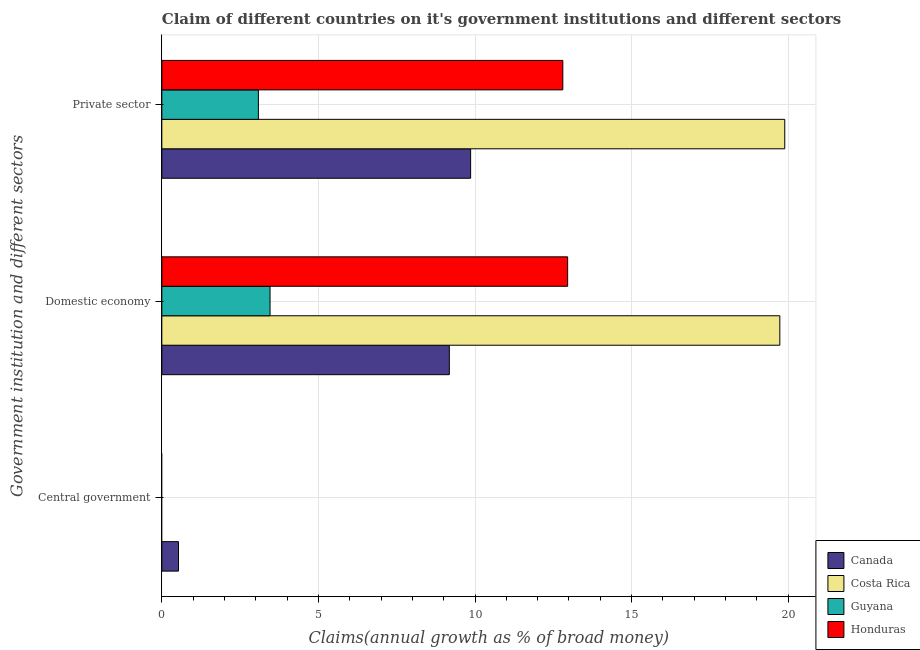Are the number of bars per tick equal to the number of legend labels?
Offer a very short reply. No. Are the number of bars on each tick of the Y-axis equal?
Give a very brief answer. No. How many bars are there on the 2nd tick from the top?
Offer a terse response. 4. How many bars are there on the 2nd tick from the bottom?
Provide a succinct answer. 4. What is the label of the 2nd group of bars from the top?
Keep it short and to the point. Domestic economy. What is the percentage of claim on the private sector in Canada?
Provide a succinct answer. 9.86. Across all countries, what is the maximum percentage of claim on the domestic economy?
Offer a terse response. 19.73. Across all countries, what is the minimum percentage of claim on the private sector?
Offer a very short reply. 3.08. In which country was the percentage of claim on the private sector maximum?
Provide a short and direct response. Costa Rica. What is the total percentage of claim on the domestic economy in the graph?
Make the answer very short. 45.33. What is the difference between the percentage of claim on the domestic economy in Guyana and that in Honduras?
Your answer should be compact. -9.5. What is the difference between the percentage of claim on the domestic economy in Costa Rica and the percentage of claim on the private sector in Canada?
Your response must be concise. 9.87. What is the average percentage of claim on the private sector per country?
Your answer should be compact. 11.41. What is the difference between the percentage of claim on the domestic economy and percentage of claim on the central government in Canada?
Provide a succinct answer. 8.65. What is the ratio of the percentage of claim on the domestic economy in Costa Rica to that in Honduras?
Provide a succinct answer. 1.52. Is the difference between the percentage of claim on the private sector in Guyana and Canada greater than the difference between the percentage of claim on the domestic economy in Guyana and Canada?
Ensure brevity in your answer.  No. What is the difference between the highest and the second highest percentage of claim on the private sector?
Make the answer very short. 7.09. What is the difference between the highest and the lowest percentage of claim on the private sector?
Provide a succinct answer. 16.81. How many bars are there?
Give a very brief answer. 9. Are all the bars in the graph horizontal?
Provide a succinct answer. Yes. How many countries are there in the graph?
Keep it short and to the point. 4. What is the difference between two consecutive major ticks on the X-axis?
Your response must be concise. 5. Does the graph contain any zero values?
Provide a succinct answer. Yes. Where does the legend appear in the graph?
Give a very brief answer. Bottom right. How many legend labels are there?
Your response must be concise. 4. What is the title of the graph?
Offer a terse response. Claim of different countries on it's government institutions and different sectors. Does "Sri Lanka" appear as one of the legend labels in the graph?
Offer a very short reply. No. What is the label or title of the X-axis?
Keep it short and to the point. Claims(annual growth as % of broad money). What is the label or title of the Y-axis?
Offer a very short reply. Government institution and different sectors. What is the Claims(annual growth as % of broad money) of Canada in Central government?
Provide a succinct answer. 0.53. What is the Claims(annual growth as % of broad money) in Costa Rica in Central government?
Give a very brief answer. 0. What is the Claims(annual growth as % of broad money) in Guyana in Central government?
Provide a succinct answer. 0. What is the Claims(annual growth as % of broad money) of Canada in Domestic economy?
Offer a very short reply. 9.18. What is the Claims(annual growth as % of broad money) in Costa Rica in Domestic economy?
Your answer should be very brief. 19.73. What is the Claims(annual growth as % of broad money) of Guyana in Domestic economy?
Keep it short and to the point. 3.46. What is the Claims(annual growth as % of broad money) of Honduras in Domestic economy?
Offer a very short reply. 12.96. What is the Claims(annual growth as % of broad money) of Canada in Private sector?
Your response must be concise. 9.86. What is the Claims(annual growth as % of broad money) in Costa Rica in Private sector?
Keep it short and to the point. 19.89. What is the Claims(annual growth as % of broad money) of Guyana in Private sector?
Provide a short and direct response. 3.08. What is the Claims(annual growth as % of broad money) in Honduras in Private sector?
Give a very brief answer. 12.8. Across all Government institution and different sectors, what is the maximum Claims(annual growth as % of broad money) of Canada?
Your answer should be very brief. 9.86. Across all Government institution and different sectors, what is the maximum Claims(annual growth as % of broad money) in Costa Rica?
Keep it short and to the point. 19.89. Across all Government institution and different sectors, what is the maximum Claims(annual growth as % of broad money) of Guyana?
Offer a very short reply. 3.46. Across all Government institution and different sectors, what is the maximum Claims(annual growth as % of broad money) of Honduras?
Your answer should be very brief. 12.96. Across all Government institution and different sectors, what is the minimum Claims(annual growth as % of broad money) in Canada?
Your answer should be compact. 0.53. Across all Government institution and different sectors, what is the minimum Claims(annual growth as % of broad money) of Costa Rica?
Provide a short and direct response. 0. What is the total Claims(annual growth as % of broad money) of Canada in the graph?
Give a very brief answer. 19.57. What is the total Claims(annual growth as % of broad money) of Costa Rica in the graph?
Offer a terse response. 39.62. What is the total Claims(annual growth as % of broad money) in Guyana in the graph?
Provide a succinct answer. 6.54. What is the total Claims(annual growth as % of broad money) of Honduras in the graph?
Give a very brief answer. 25.76. What is the difference between the Claims(annual growth as % of broad money) in Canada in Central government and that in Domestic economy?
Your answer should be compact. -8.65. What is the difference between the Claims(annual growth as % of broad money) of Canada in Central government and that in Private sector?
Your answer should be compact. -9.33. What is the difference between the Claims(annual growth as % of broad money) of Canada in Domestic economy and that in Private sector?
Give a very brief answer. -0.68. What is the difference between the Claims(annual growth as % of broad money) in Costa Rica in Domestic economy and that in Private sector?
Make the answer very short. -0.16. What is the difference between the Claims(annual growth as % of broad money) of Guyana in Domestic economy and that in Private sector?
Provide a succinct answer. 0.37. What is the difference between the Claims(annual growth as % of broad money) in Honduras in Domestic economy and that in Private sector?
Ensure brevity in your answer.  0.15. What is the difference between the Claims(annual growth as % of broad money) in Canada in Central government and the Claims(annual growth as % of broad money) in Costa Rica in Domestic economy?
Offer a terse response. -19.2. What is the difference between the Claims(annual growth as % of broad money) of Canada in Central government and the Claims(annual growth as % of broad money) of Guyana in Domestic economy?
Keep it short and to the point. -2.92. What is the difference between the Claims(annual growth as % of broad money) in Canada in Central government and the Claims(annual growth as % of broad money) in Honduras in Domestic economy?
Ensure brevity in your answer.  -12.43. What is the difference between the Claims(annual growth as % of broad money) in Canada in Central government and the Claims(annual growth as % of broad money) in Costa Rica in Private sector?
Offer a terse response. -19.36. What is the difference between the Claims(annual growth as % of broad money) of Canada in Central government and the Claims(annual growth as % of broad money) of Guyana in Private sector?
Offer a very short reply. -2.55. What is the difference between the Claims(annual growth as % of broad money) in Canada in Central government and the Claims(annual growth as % of broad money) in Honduras in Private sector?
Keep it short and to the point. -12.27. What is the difference between the Claims(annual growth as % of broad money) in Canada in Domestic economy and the Claims(annual growth as % of broad money) in Costa Rica in Private sector?
Your answer should be very brief. -10.71. What is the difference between the Claims(annual growth as % of broad money) of Canada in Domestic economy and the Claims(annual growth as % of broad money) of Guyana in Private sector?
Make the answer very short. 6.1. What is the difference between the Claims(annual growth as % of broad money) in Canada in Domestic economy and the Claims(annual growth as % of broad money) in Honduras in Private sector?
Your answer should be very brief. -3.62. What is the difference between the Claims(annual growth as % of broad money) of Costa Rica in Domestic economy and the Claims(annual growth as % of broad money) of Guyana in Private sector?
Make the answer very short. 16.65. What is the difference between the Claims(annual growth as % of broad money) of Costa Rica in Domestic economy and the Claims(annual growth as % of broad money) of Honduras in Private sector?
Ensure brevity in your answer.  6.93. What is the difference between the Claims(annual growth as % of broad money) in Guyana in Domestic economy and the Claims(annual growth as % of broad money) in Honduras in Private sector?
Offer a very short reply. -9.35. What is the average Claims(annual growth as % of broad money) in Canada per Government institution and different sectors?
Give a very brief answer. 6.52. What is the average Claims(annual growth as % of broad money) in Costa Rica per Government institution and different sectors?
Keep it short and to the point. 13.21. What is the average Claims(annual growth as % of broad money) in Guyana per Government institution and different sectors?
Your answer should be very brief. 2.18. What is the average Claims(annual growth as % of broad money) of Honduras per Government institution and different sectors?
Give a very brief answer. 8.59. What is the difference between the Claims(annual growth as % of broad money) in Canada and Claims(annual growth as % of broad money) in Costa Rica in Domestic economy?
Your response must be concise. -10.55. What is the difference between the Claims(annual growth as % of broad money) in Canada and Claims(annual growth as % of broad money) in Guyana in Domestic economy?
Keep it short and to the point. 5.73. What is the difference between the Claims(annual growth as % of broad money) of Canada and Claims(annual growth as % of broad money) of Honduras in Domestic economy?
Provide a short and direct response. -3.78. What is the difference between the Claims(annual growth as % of broad money) of Costa Rica and Claims(annual growth as % of broad money) of Guyana in Domestic economy?
Offer a terse response. 16.28. What is the difference between the Claims(annual growth as % of broad money) in Costa Rica and Claims(annual growth as % of broad money) in Honduras in Domestic economy?
Your answer should be compact. 6.78. What is the difference between the Claims(annual growth as % of broad money) in Guyana and Claims(annual growth as % of broad money) in Honduras in Domestic economy?
Make the answer very short. -9.5. What is the difference between the Claims(annual growth as % of broad money) of Canada and Claims(annual growth as % of broad money) of Costa Rica in Private sector?
Your response must be concise. -10.03. What is the difference between the Claims(annual growth as % of broad money) in Canada and Claims(annual growth as % of broad money) in Guyana in Private sector?
Make the answer very short. 6.78. What is the difference between the Claims(annual growth as % of broad money) of Canada and Claims(annual growth as % of broad money) of Honduras in Private sector?
Keep it short and to the point. -2.94. What is the difference between the Claims(annual growth as % of broad money) of Costa Rica and Claims(annual growth as % of broad money) of Guyana in Private sector?
Offer a very short reply. 16.81. What is the difference between the Claims(annual growth as % of broad money) of Costa Rica and Claims(annual growth as % of broad money) of Honduras in Private sector?
Your response must be concise. 7.09. What is the difference between the Claims(annual growth as % of broad money) in Guyana and Claims(annual growth as % of broad money) in Honduras in Private sector?
Give a very brief answer. -9.72. What is the ratio of the Claims(annual growth as % of broad money) of Canada in Central government to that in Domestic economy?
Your answer should be compact. 0.06. What is the ratio of the Claims(annual growth as % of broad money) of Canada in Central government to that in Private sector?
Provide a short and direct response. 0.05. What is the ratio of the Claims(annual growth as % of broad money) in Canada in Domestic economy to that in Private sector?
Your answer should be very brief. 0.93. What is the ratio of the Claims(annual growth as % of broad money) of Costa Rica in Domestic economy to that in Private sector?
Offer a terse response. 0.99. What is the ratio of the Claims(annual growth as % of broad money) in Guyana in Domestic economy to that in Private sector?
Make the answer very short. 1.12. What is the difference between the highest and the second highest Claims(annual growth as % of broad money) of Canada?
Keep it short and to the point. 0.68. What is the difference between the highest and the lowest Claims(annual growth as % of broad money) in Canada?
Your response must be concise. 9.33. What is the difference between the highest and the lowest Claims(annual growth as % of broad money) of Costa Rica?
Give a very brief answer. 19.89. What is the difference between the highest and the lowest Claims(annual growth as % of broad money) in Guyana?
Your answer should be compact. 3.46. What is the difference between the highest and the lowest Claims(annual growth as % of broad money) in Honduras?
Your answer should be very brief. 12.96. 